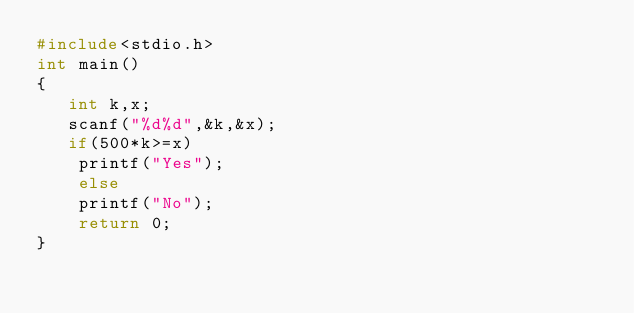<code> <loc_0><loc_0><loc_500><loc_500><_C_>#include<stdio.h>
int main()
{
   int k,x;
   scanf("%d%d",&k,&x);
   if(500*k>=x)
    printf("Yes");
    else
    printf("No");
    return 0;
}
</code> 